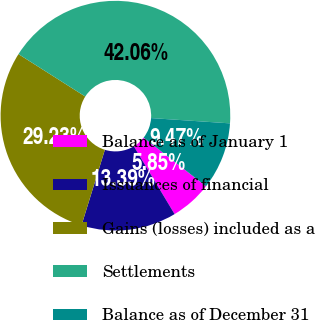Convert chart to OTSL. <chart><loc_0><loc_0><loc_500><loc_500><pie_chart><fcel>Balance as of January 1<fcel>Issuances of financial<fcel>Gains (losses) included as a<fcel>Settlements<fcel>Balance as of December 31<nl><fcel>5.85%<fcel>13.39%<fcel>29.23%<fcel>42.06%<fcel>9.47%<nl></chart> 